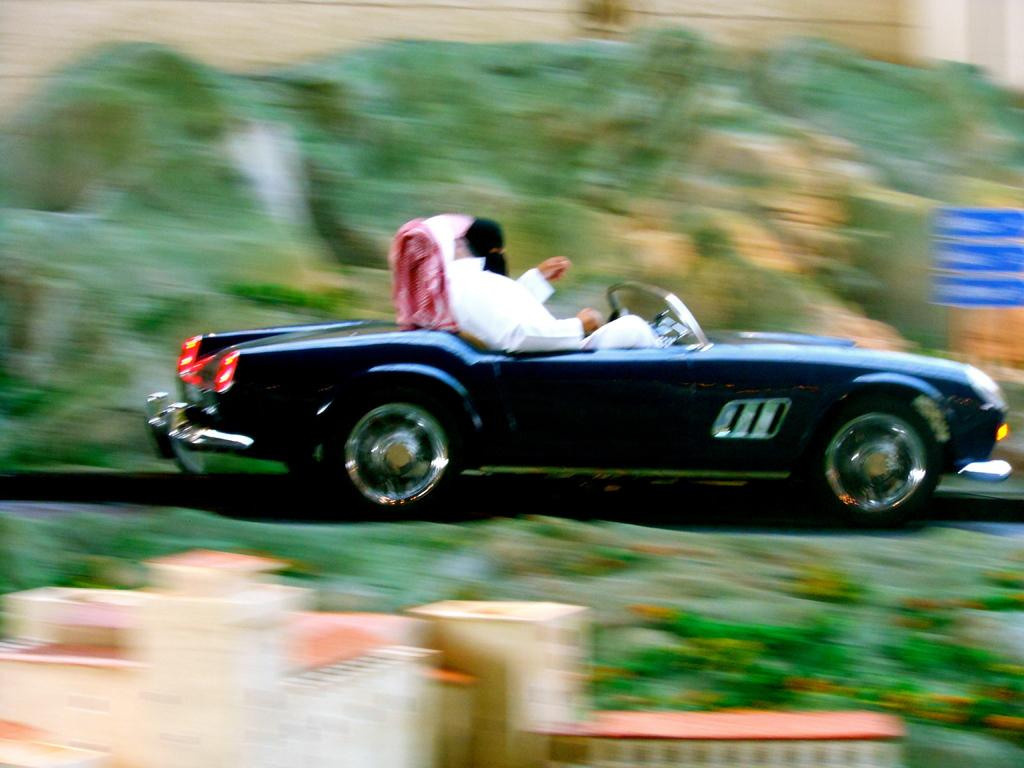What are the people in the image doing? The people in the image are sitting in a car. What can be seen in the background of the image? There are buildings and trees visible in the image. What type of signs or notices are present in the image? There are boards with text in the image. What language is the bear speaking in the image? There is no bear present in the image, so it is not possible to determine the language it might be speaking. 